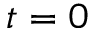Convert formula to latex. <formula><loc_0><loc_0><loc_500><loc_500>t = 0</formula> 